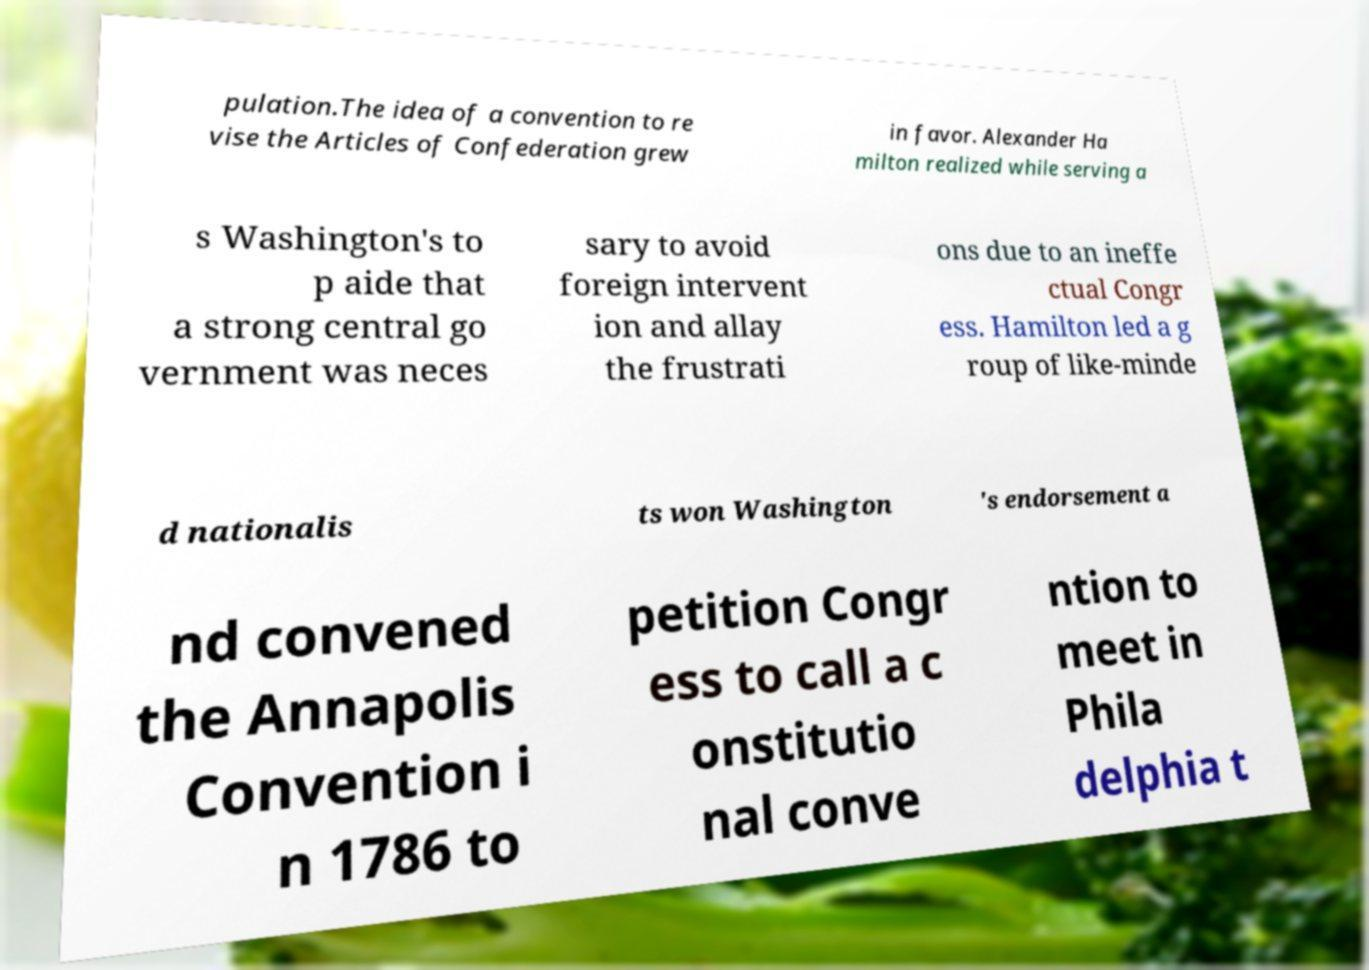I need the written content from this picture converted into text. Can you do that? pulation.The idea of a convention to re vise the Articles of Confederation grew in favor. Alexander Ha milton realized while serving a s Washington's to p aide that a strong central go vernment was neces sary to avoid foreign intervent ion and allay the frustrati ons due to an ineffe ctual Congr ess. Hamilton led a g roup of like-minde d nationalis ts won Washington 's endorsement a nd convened the Annapolis Convention i n 1786 to petition Congr ess to call a c onstitutio nal conve ntion to meet in Phila delphia t 